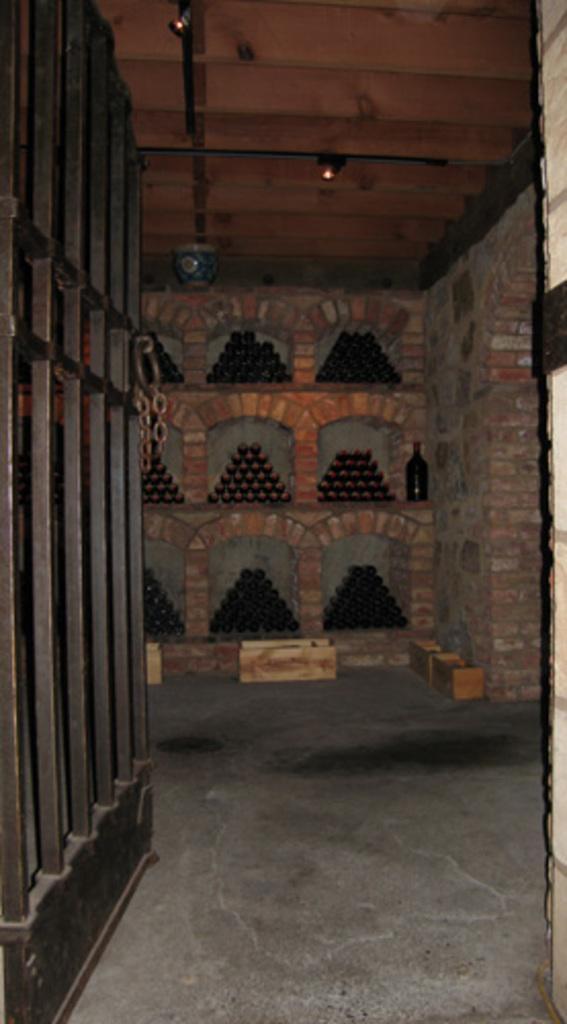Can you describe this image briefly? We can see gate and floor. In the background we can see objects in shelves and bottle. Top we can see lights. 